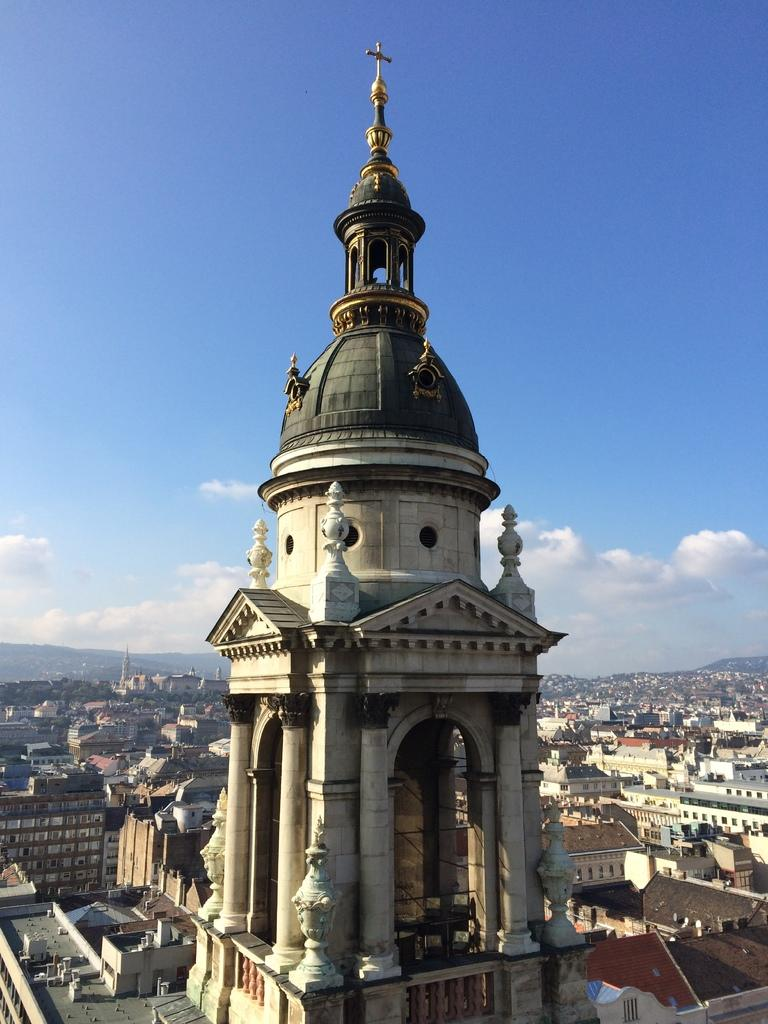What type of building is depicted in the image? There is a building with a cross at the top in the image. Are there any other buildings visible in the image? Yes, there are other buildings behind the main building. What natural feature can be seen in the background of the image? Mountains are visible in the image. What is the condition of the sky in the image? The sky in the image has clouds. What type of observation can be made about the earth from the image? The image does not provide any information about the earth or any observations related to it. 